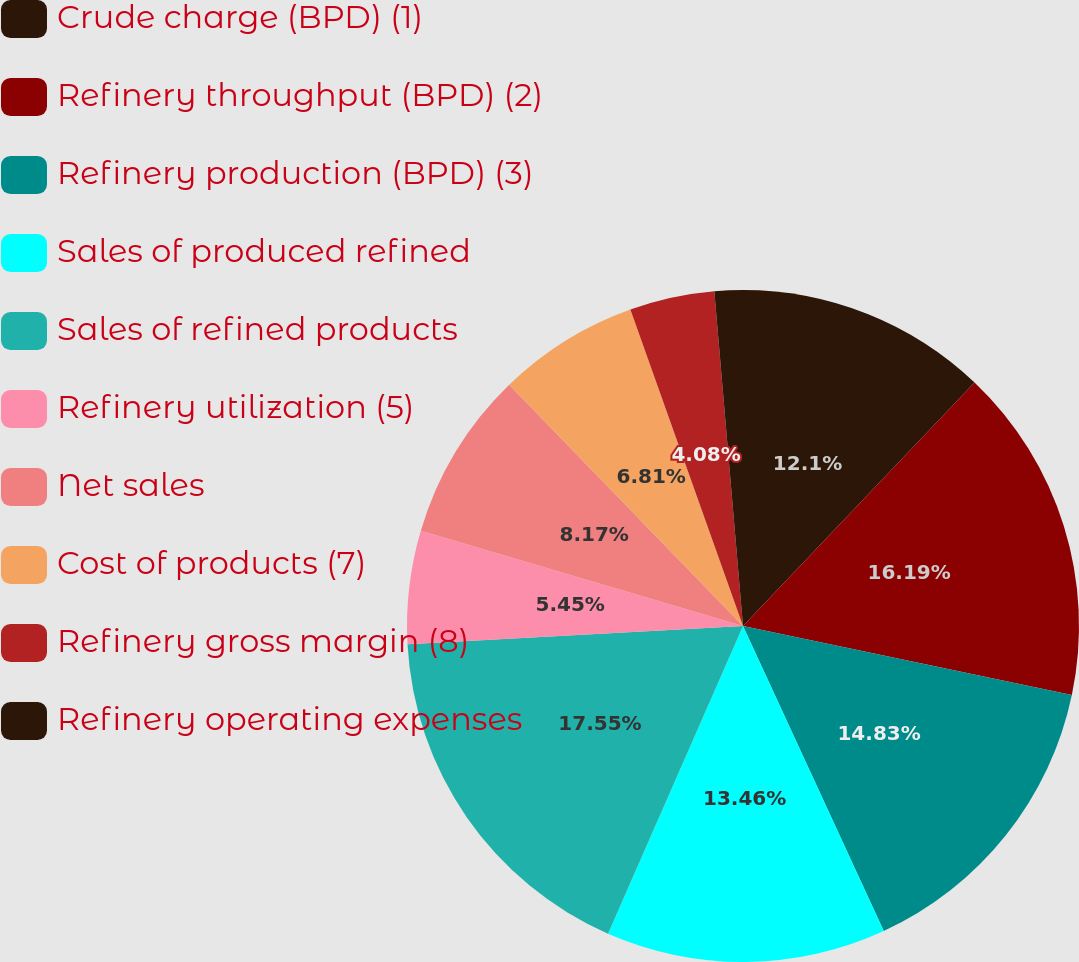<chart> <loc_0><loc_0><loc_500><loc_500><pie_chart><fcel>Crude charge (BPD) (1)<fcel>Refinery throughput (BPD) (2)<fcel>Refinery production (BPD) (3)<fcel>Sales of produced refined<fcel>Sales of refined products<fcel>Refinery utilization (5)<fcel>Net sales<fcel>Cost of products (7)<fcel>Refinery gross margin (8)<fcel>Refinery operating expenses<nl><fcel>12.1%<fcel>16.19%<fcel>14.83%<fcel>13.46%<fcel>17.55%<fcel>5.45%<fcel>8.17%<fcel>6.81%<fcel>4.08%<fcel>1.36%<nl></chart> 